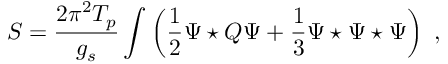<formula> <loc_0><loc_0><loc_500><loc_500>S = \frac { 2 \pi ^ { 2 } T _ { p } } { g _ { s } } \int \left ( \frac { 1 } { 2 } \Psi ^ { * } Q \Psi + \frac { 1 } { 3 } \Psi ^ { * } \Psi ^ { * } \Psi \right ) \ ,</formula> 